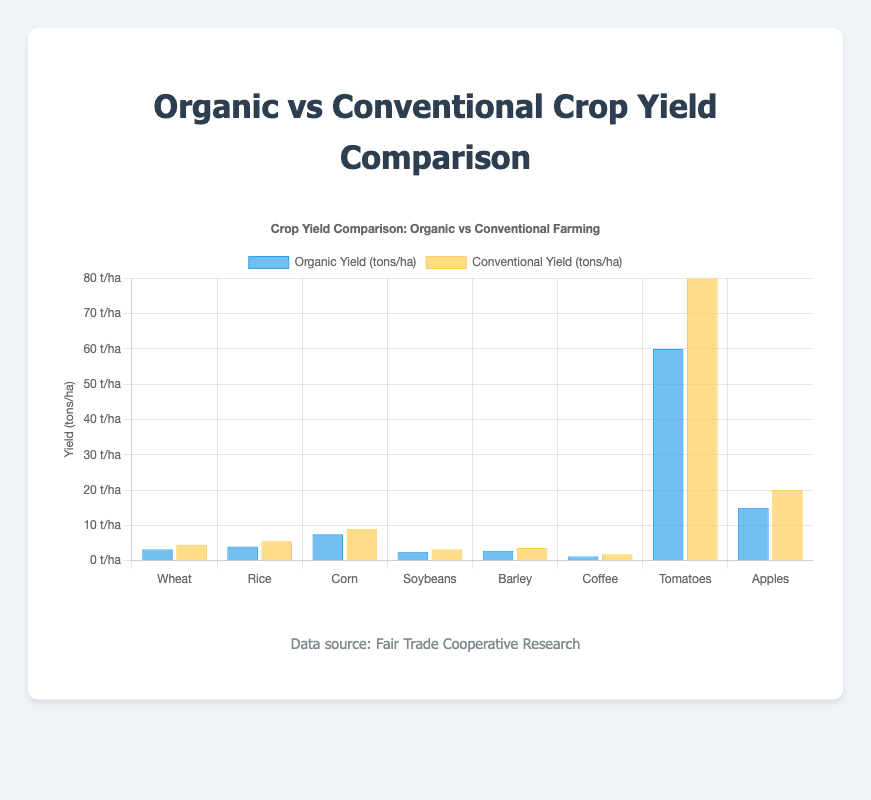Which crop has the highest organic yield? To find the crop with the highest organic yield, look at the heights of the blue bars representing organic yield. The tallest blue bar corresponds to "Tomatoes" with an organic yield of 60 tons/ha.
Answer: Tomatoes What is the difference in yield between organic and conventional farming for coffee? First, identify the yields for organic and conventional coffee: Organic yield is 1.2 tons/ha, and conventional yield is 1.8 tons/ha. Subtract the organic yield from the conventional yield: 1.8 - 1.2 = 0.6 tons/ha.
Answer: 0.6 tons/ha Which crop shows the largest gap in yield between organic and conventional farming? Calculate the yield difference for each crop: Wheat (4.5 - 3.2 = 1.3), Rice (5.5 - 4.0 = 1.5), Corn (9.0 - 7.5 = 1.5), Soybeans (3.2 - 2.5 = 0.7), Barley (3.6 - 2.8 = 0.8), Coffee (1.8 - 1.2 = 0.6), Tomatoes (80.0 - 60.0 = 20), Apples (20.0 - 15.0 = 5). The largest difference is for Tomatoes with a 20 tons/ha gap.
Answer: Tomatoes What is the combined yield of organic wheat and organic rice? Add the organic yields of wheat and rice: Wheat (3.2 tons/ha) + Rice (4.0 tons/ha) = 7.2 tons/ha.
Answer: 7.2 tons/ha Which farming practice has a higher average yield for the crops listed? Calculate the average yield for both farming practices. For organic: (3.2 + 4.0 + 7.5 + 2.5 + 2.8 + 1.2 + 60.0 + 15.0) / 8 = 12.775 tons/ha. For conventional: (4.5 + 5.5 + 9.0 + 3.2 + 3.6 + 1.8 + 80.0 + 20.0) / 8 = 15.7 tons/ha. Conventional farming has a higher average yield.
Answer: Conventional How much more yield, in percentage terms, does conventional farming produce compared to organic farming for corn? Find the yields for corn: Organic yield is 7.5 tons/ha, and conventional yield is 9.0 tons/ha. Calculate the percentage increase: ((9.0 - 7.5) / 7.5) * 100 = 20%.
Answer: 20% Which crop has the smallest difference in yield between organic and conventional farming? Calculate the yield difference for each crop: Wheat (1.3), Rice (1.5), Corn (1.5), Soybeans (0.7), Barley (0.8), Coffee (0.6), Tomatoes (20.0), Apples (5.0). The smallest difference is for Coffee with 0.6 tons/ha.
Answer: Coffee How many crops have a conventional yield that is at least 2 times the organic yield? For each crop, check if the conventional yield is at least double the organic yield: Wheat (4.5 / 3.2 ≈ 1.41), Rice (5.5 / 4.0 = 1.375), Corn (9.0 / 7.5 = 1.2), Soybeans (3.2 / 2.5 = 1.28), Barley (3.6 / 2.8 ≈ 1.29), Coffee (1.8 / 1.2 = 1.5), Tomatoes (80.0 / 60.0 ≈ 1.33), Apples (20.0 / 15.0 = 1.33). None of the ratios are at least 2.
Answer: 0 What is the total conventional yield for all crops listed? Sum the conventional yields of all crops: 4.5 + 5.5 + 9.0 + 3.2 + 3.6 + 1.8 + 80.0 + 20.0 = 127.6 tons/ha.
Answer: 127.6 tons/ha 